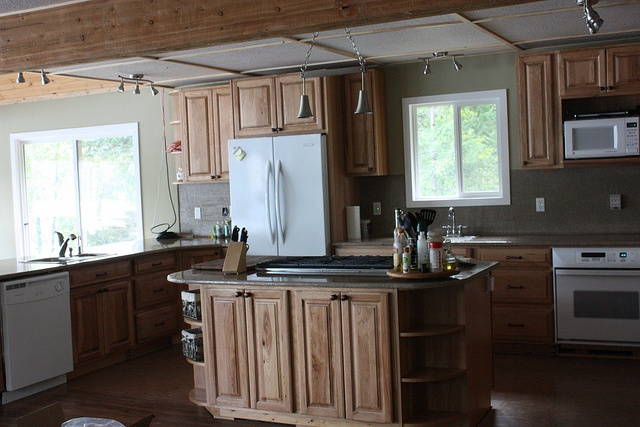Describe the objects in this image and their specific colors. I can see refrigerator in gray, lavender, lightblue, and darkgray tones, oven in gray and black tones, microwave in gray tones, sink in gray, lightgray, darkgray, and black tones, and bottle in gray, maroon, black, and darkgray tones in this image. 